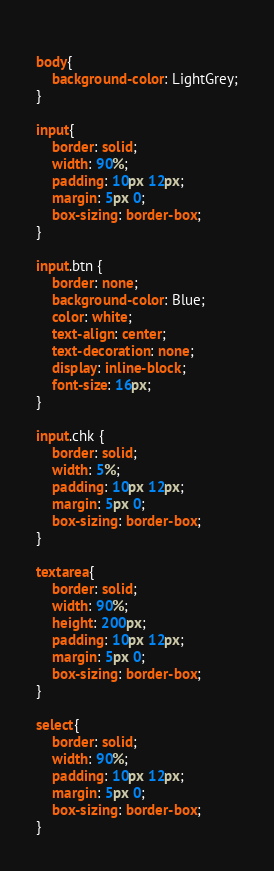<code> <loc_0><loc_0><loc_500><loc_500><_CSS_>				
body{
    background-color: LightGrey;
}

input{
	border: solid;
	width: 90%;
	padding: 10px 12px;
	margin: 5px 0;
	box-sizing: border-box;
}

input.btn {
    border: none;
    background-color: Blue;
    color: white;
    text-align: center;
    text-decoration: none;
    display: inline-block;
    font-size: 16px;
}

input.chk {
	border: solid;
	width: 5%;
	padding: 10px 12px;
	margin: 5px 0;
	box-sizing: border-box;
}

textarea{
	border: solid;
	width: 90%;
	height: 200px;
	padding: 10px 12px;
	margin: 5px 0;
	box-sizing: border-box;
}

select{
	border: solid;
	width: 90%;
	padding: 10px 12px;
	margin: 5px 0;
	box-sizing: border-box;
}
</code> 